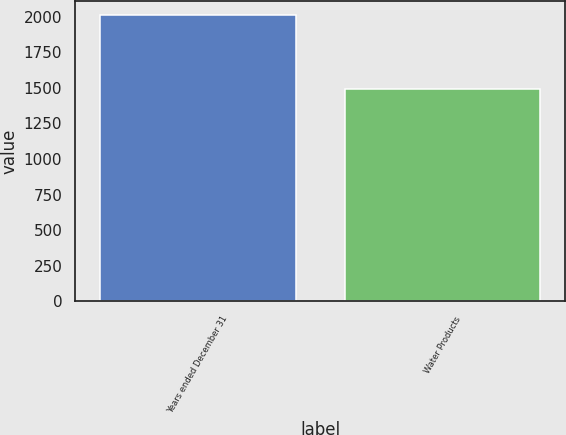Convert chart to OTSL. <chart><loc_0><loc_0><loc_500><loc_500><bar_chart><fcel>Years ended December 31<fcel>Water Products<nl><fcel>2010<fcel>1489.3<nl></chart> 